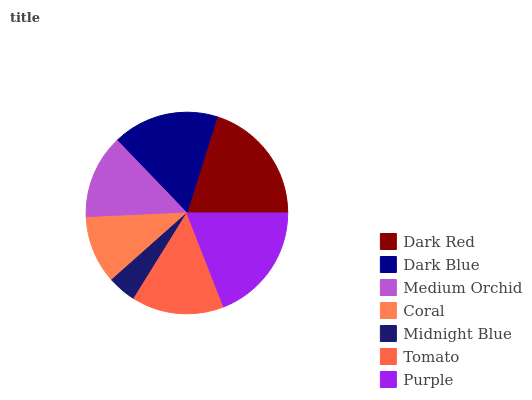Is Midnight Blue the minimum?
Answer yes or no. Yes. Is Dark Red the maximum?
Answer yes or no. Yes. Is Dark Blue the minimum?
Answer yes or no. No. Is Dark Blue the maximum?
Answer yes or no. No. Is Dark Red greater than Dark Blue?
Answer yes or no. Yes. Is Dark Blue less than Dark Red?
Answer yes or no. Yes. Is Dark Blue greater than Dark Red?
Answer yes or no. No. Is Dark Red less than Dark Blue?
Answer yes or no. No. Is Tomato the high median?
Answer yes or no. Yes. Is Tomato the low median?
Answer yes or no. Yes. Is Coral the high median?
Answer yes or no. No. Is Purple the low median?
Answer yes or no. No. 